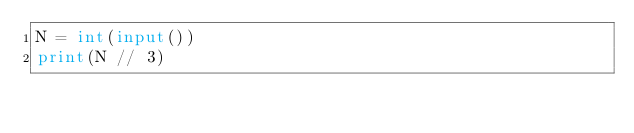<code> <loc_0><loc_0><loc_500><loc_500><_Python_>N = int(input())
print(N // 3)</code> 